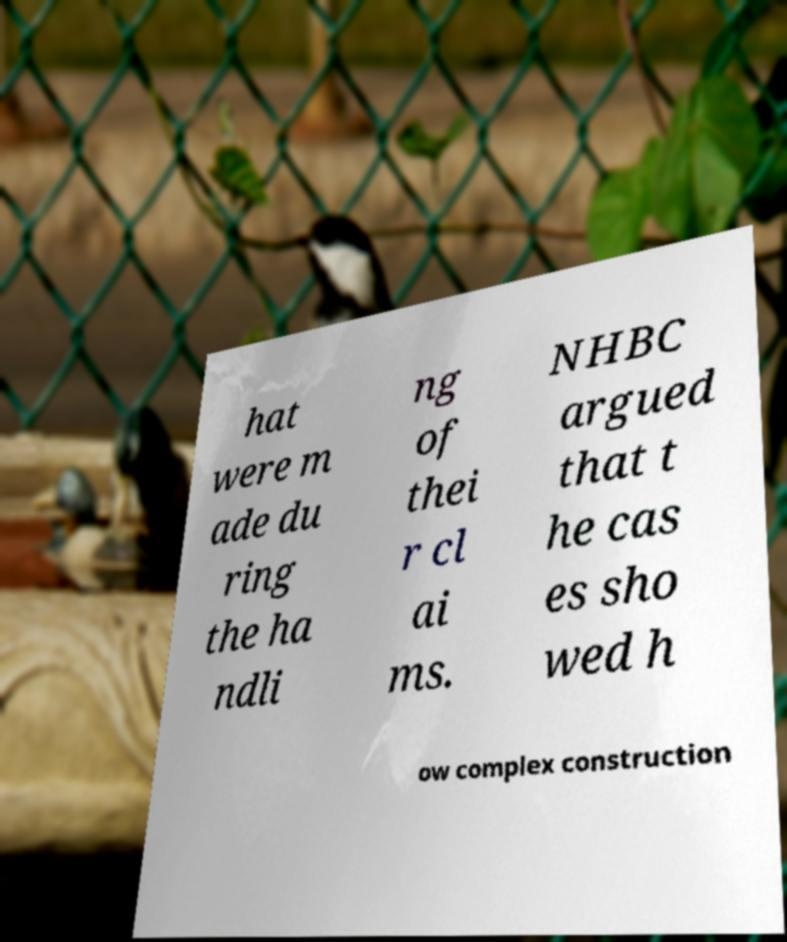Please identify and transcribe the text found in this image. hat were m ade du ring the ha ndli ng of thei r cl ai ms. NHBC argued that t he cas es sho wed h ow complex construction 